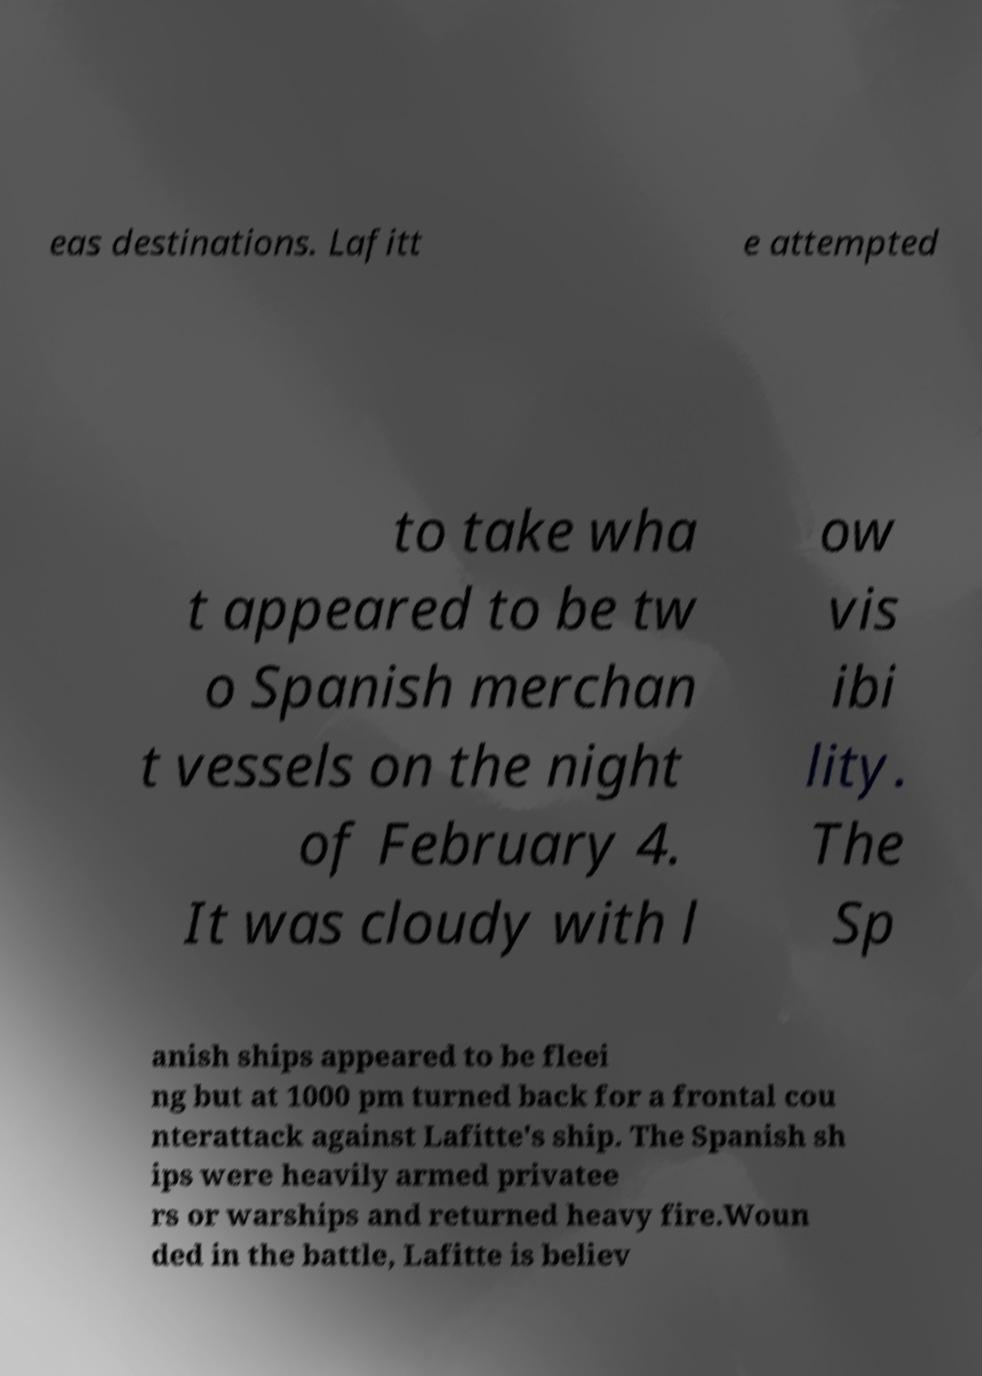I need the written content from this picture converted into text. Can you do that? eas destinations. Lafitt e attempted to take wha t appeared to be tw o Spanish merchan t vessels on the night of February 4. It was cloudy with l ow vis ibi lity. The Sp anish ships appeared to be fleei ng but at 1000 pm turned back for a frontal cou nterattack against Lafitte's ship. The Spanish sh ips were heavily armed privatee rs or warships and returned heavy fire.Woun ded in the battle, Lafitte is believ 